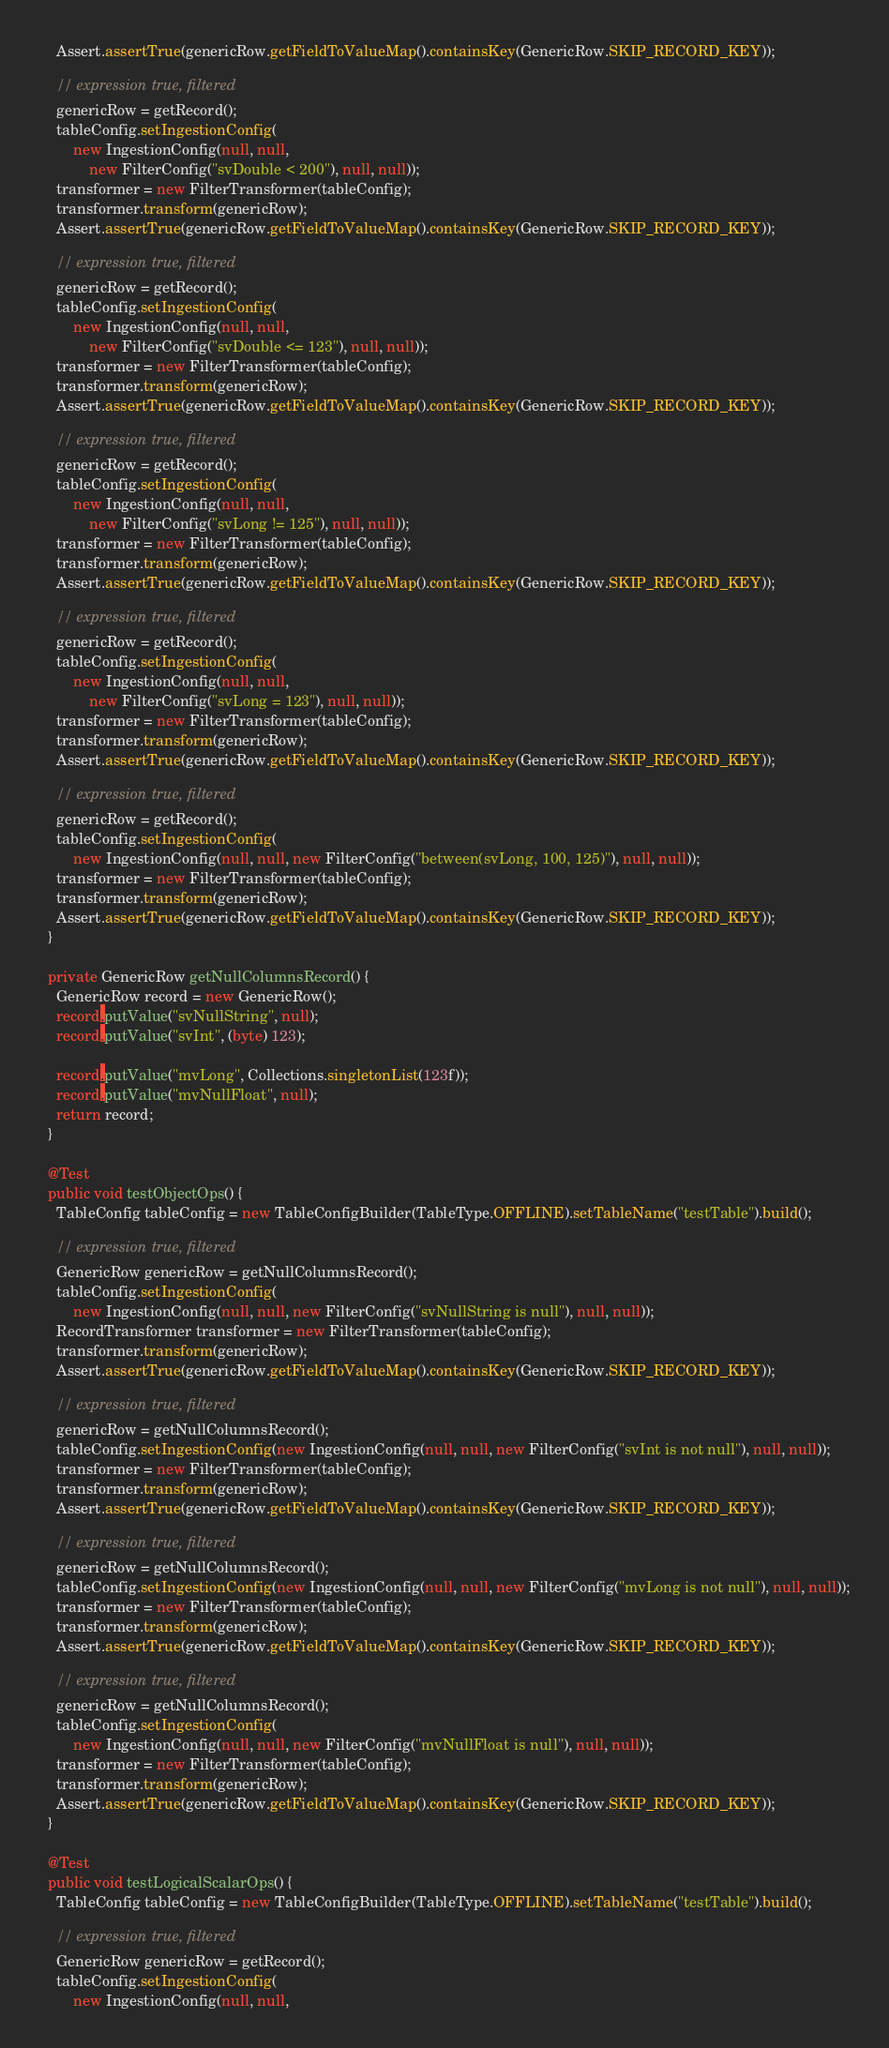Convert code to text. <code><loc_0><loc_0><loc_500><loc_500><_Java_>    Assert.assertTrue(genericRow.getFieldToValueMap().containsKey(GenericRow.SKIP_RECORD_KEY));

    // expression true, filtered
    genericRow = getRecord();
    tableConfig.setIngestionConfig(
        new IngestionConfig(null, null,
            new FilterConfig("svDouble < 200"), null, null));
    transformer = new FilterTransformer(tableConfig);
    transformer.transform(genericRow);
    Assert.assertTrue(genericRow.getFieldToValueMap().containsKey(GenericRow.SKIP_RECORD_KEY));

    // expression true, filtered
    genericRow = getRecord();
    tableConfig.setIngestionConfig(
        new IngestionConfig(null, null,
            new FilterConfig("svDouble <= 123"), null, null));
    transformer = new FilterTransformer(tableConfig);
    transformer.transform(genericRow);
    Assert.assertTrue(genericRow.getFieldToValueMap().containsKey(GenericRow.SKIP_RECORD_KEY));

    // expression true, filtered
    genericRow = getRecord();
    tableConfig.setIngestionConfig(
        new IngestionConfig(null, null,
            new FilterConfig("svLong != 125"), null, null));
    transformer = new FilterTransformer(tableConfig);
    transformer.transform(genericRow);
    Assert.assertTrue(genericRow.getFieldToValueMap().containsKey(GenericRow.SKIP_RECORD_KEY));

    // expression true, filtered
    genericRow = getRecord();
    tableConfig.setIngestionConfig(
        new IngestionConfig(null, null,
            new FilterConfig("svLong = 123"), null, null));
    transformer = new FilterTransformer(tableConfig);
    transformer.transform(genericRow);
    Assert.assertTrue(genericRow.getFieldToValueMap().containsKey(GenericRow.SKIP_RECORD_KEY));

    // expression true, filtered
    genericRow = getRecord();
    tableConfig.setIngestionConfig(
        new IngestionConfig(null, null, new FilterConfig("between(svLong, 100, 125)"), null, null));
    transformer = new FilterTransformer(tableConfig);
    transformer.transform(genericRow);
    Assert.assertTrue(genericRow.getFieldToValueMap().containsKey(GenericRow.SKIP_RECORD_KEY));
  }

  private GenericRow getNullColumnsRecord() {
    GenericRow record = new GenericRow();
    record.putValue("svNullString", null);
    record.putValue("svInt", (byte) 123);

    record.putValue("mvLong", Collections.singletonList(123f));
    record.putValue("mvNullFloat", null);
    return record;
  }

  @Test
  public void testObjectOps() {
    TableConfig tableConfig = new TableConfigBuilder(TableType.OFFLINE).setTableName("testTable").build();

    // expression true, filtered
    GenericRow genericRow = getNullColumnsRecord();
    tableConfig.setIngestionConfig(
        new IngestionConfig(null, null, new FilterConfig("svNullString is null"), null, null));
    RecordTransformer transformer = new FilterTransformer(tableConfig);
    transformer.transform(genericRow);
    Assert.assertTrue(genericRow.getFieldToValueMap().containsKey(GenericRow.SKIP_RECORD_KEY));

    // expression true, filtered
    genericRow = getNullColumnsRecord();
    tableConfig.setIngestionConfig(new IngestionConfig(null, null, new FilterConfig("svInt is not null"), null, null));
    transformer = new FilterTransformer(tableConfig);
    transformer.transform(genericRow);
    Assert.assertTrue(genericRow.getFieldToValueMap().containsKey(GenericRow.SKIP_RECORD_KEY));

    // expression true, filtered
    genericRow = getNullColumnsRecord();
    tableConfig.setIngestionConfig(new IngestionConfig(null, null, new FilterConfig("mvLong is not null"), null, null));
    transformer = new FilterTransformer(tableConfig);
    transformer.transform(genericRow);
    Assert.assertTrue(genericRow.getFieldToValueMap().containsKey(GenericRow.SKIP_RECORD_KEY));

    // expression true, filtered
    genericRow = getNullColumnsRecord();
    tableConfig.setIngestionConfig(
        new IngestionConfig(null, null, new FilterConfig("mvNullFloat is null"), null, null));
    transformer = new FilterTransformer(tableConfig);
    transformer.transform(genericRow);
    Assert.assertTrue(genericRow.getFieldToValueMap().containsKey(GenericRow.SKIP_RECORD_KEY));
  }

  @Test
  public void testLogicalScalarOps() {
    TableConfig tableConfig = new TableConfigBuilder(TableType.OFFLINE).setTableName("testTable").build();

    // expression true, filtered
    GenericRow genericRow = getRecord();
    tableConfig.setIngestionConfig(
        new IngestionConfig(null, null,</code> 